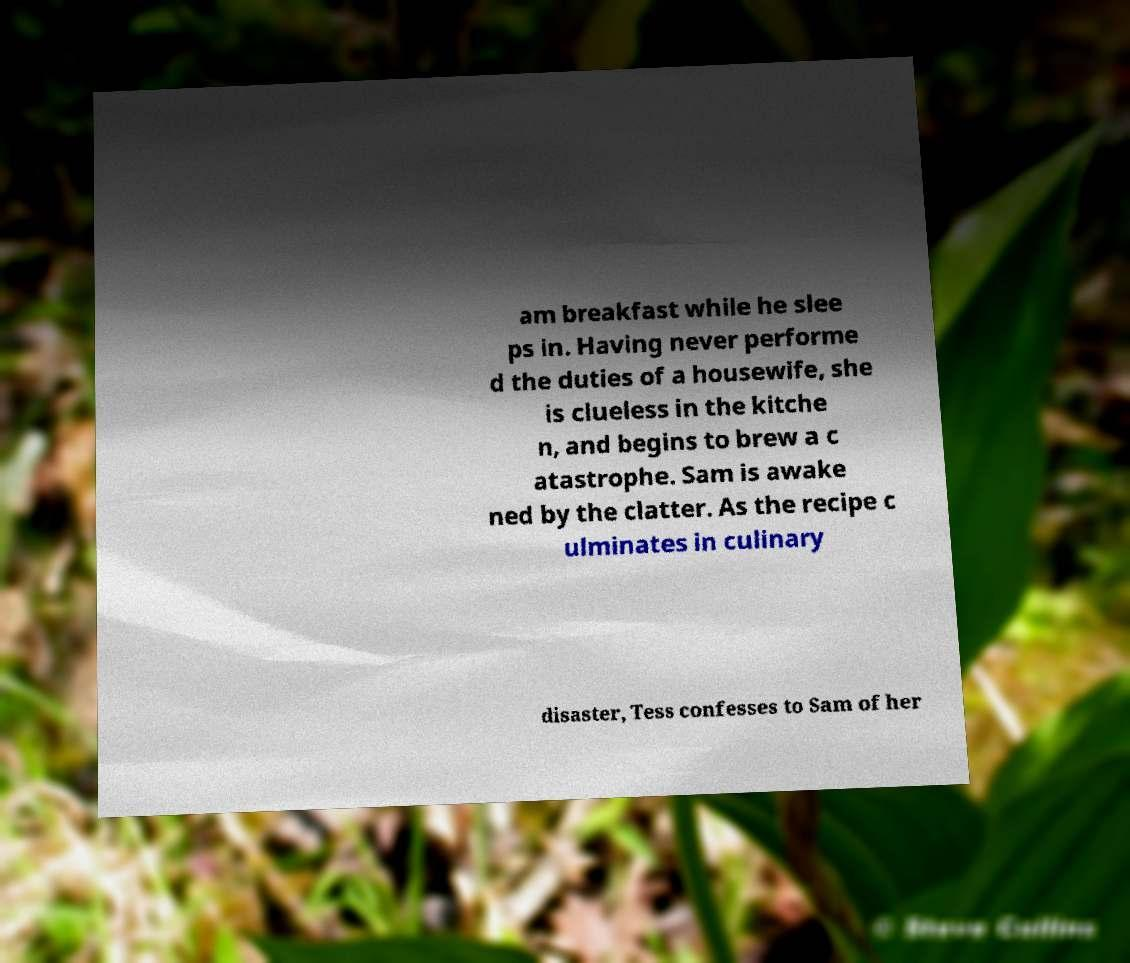Please read and relay the text visible in this image. What does it say? am breakfast while he slee ps in. Having never performe d the duties of a housewife, she is clueless in the kitche n, and begins to brew a c atastrophe. Sam is awake ned by the clatter. As the recipe c ulminates in culinary disaster, Tess confesses to Sam of her 